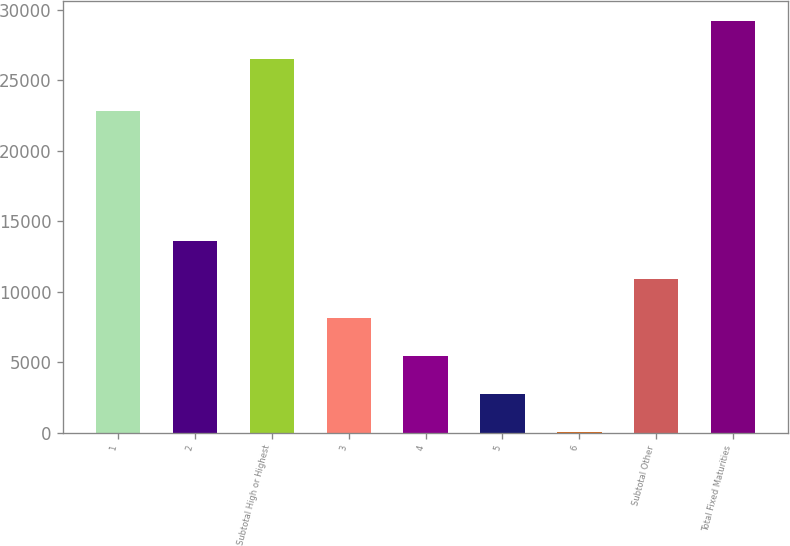Convert chart. <chart><loc_0><loc_0><loc_500><loc_500><bar_chart><fcel>1<fcel>2<fcel>Subtotal High or Highest<fcel>3<fcel>4<fcel>5<fcel>6<fcel>Subtotal Other<fcel>Total Fixed Maturities<nl><fcel>22783<fcel>13578.5<fcel>26481<fcel>8155.1<fcel>5443.4<fcel>2731.7<fcel>20<fcel>10866.8<fcel>29192.7<nl></chart> 